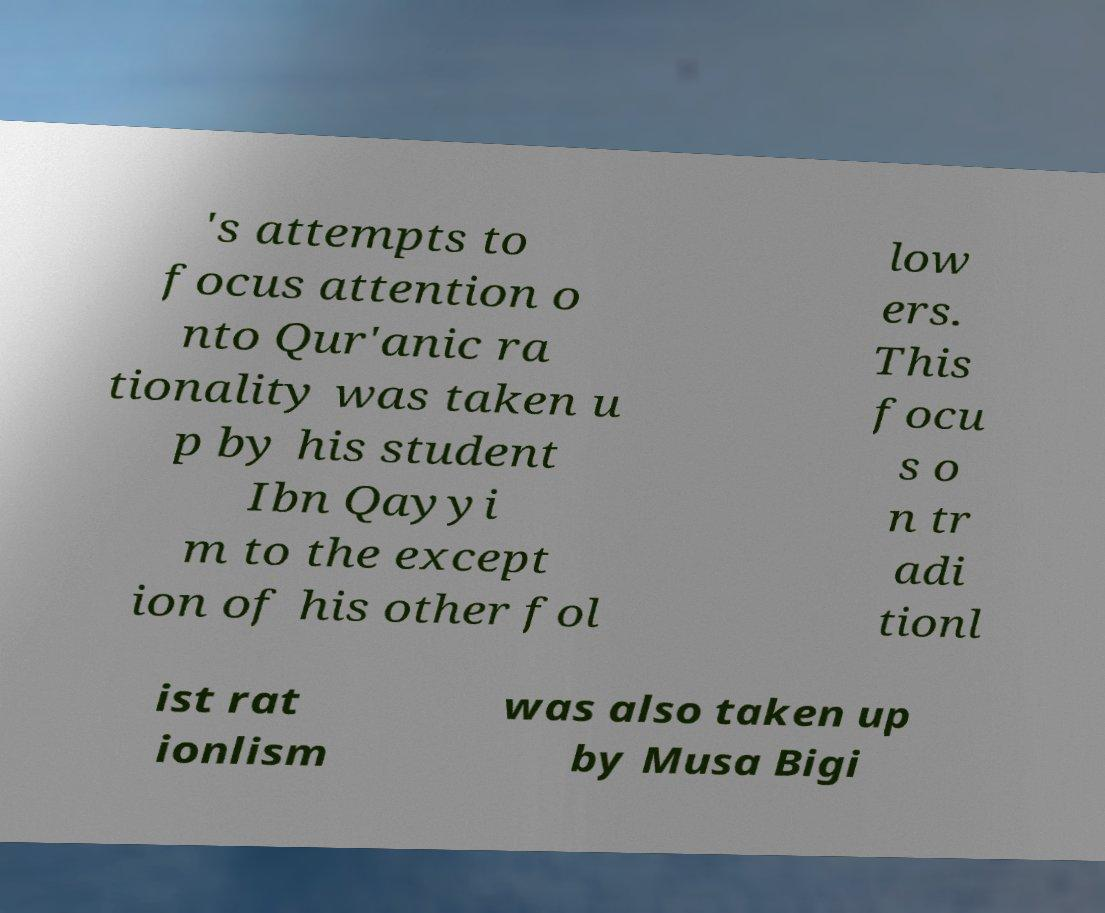Could you extract and type out the text from this image? 's attempts to focus attention o nto Qur'anic ra tionality was taken u p by his student Ibn Qayyi m to the except ion of his other fol low ers. This focu s o n tr adi tionl ist rat ionlism was also taken up by Musa Bigi 